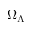<formula> <loc_0><loc_0><loc_500><loc_500>\Omega _ { \Lambda }</formula> 